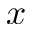<formula> <loc_0><loc_0><loc_500><loc_500>x</formula> 